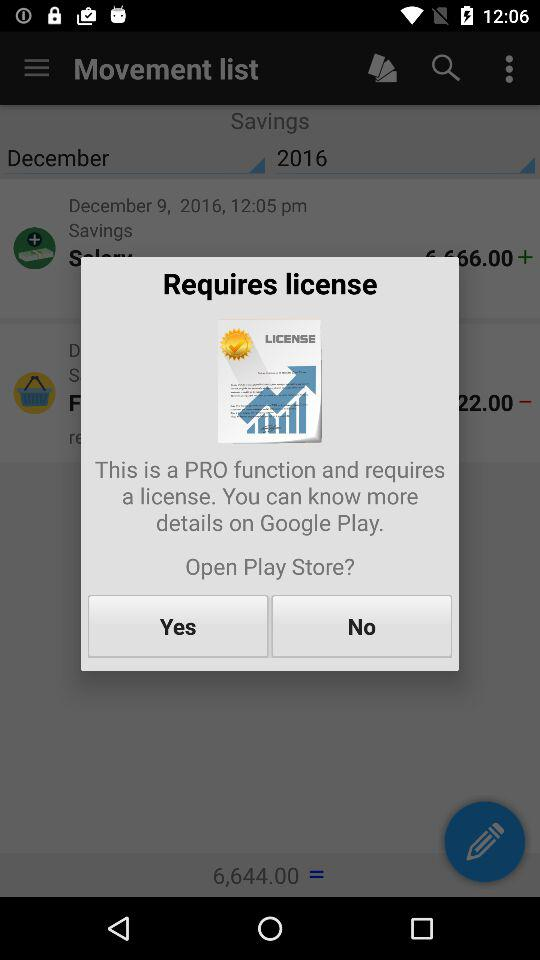Which month and year are the savings for? The month is December and the year is 2016. 